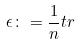Convert formula to latex. <formula><loc_0><loc_0><loc_500><loc_500>\epsilon \colon = \frac { 1 } { n } t r</formula> 